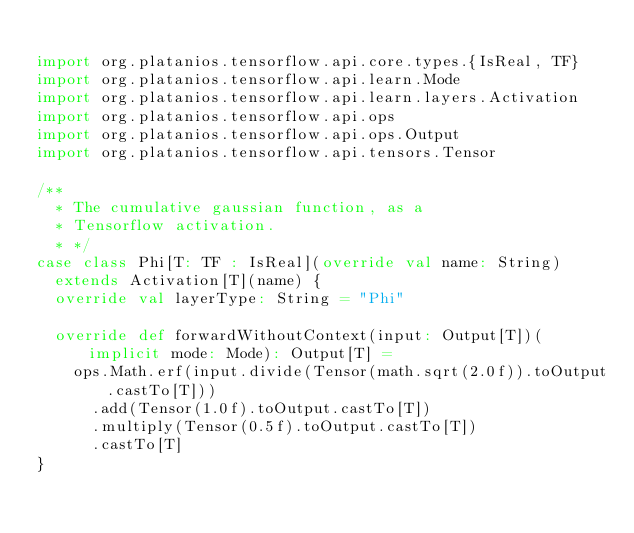<code> <loc_0><loc_0><loc_500><loc_500><_Scala_>
import org.platanios.tensorflow.api.core.types.{IsReal, TF}
import org.platanios.tensorflow.api.learn.Mode
import org.platanios.tensorflow.api.learn.layers.Activation
import org.platanios.tensorflow.api.ops
import org.platanios.tensorflow.api.ops.Output
import org.platanios.tensorflow.api.tensors.Tensor

/**
  * The cumulative gaussian function, as a
  * Tensorflow activation.
  * */
case class Phi[T: TF : IsReal](override val name: String)
  extends Activation[T](name) {
  override val layerType: String = "Phi"

  override def forwardWithoutContext(input: Output[T])(implicit mode: Mode): Output[T] =
    ops.Math.erf(input.divide(Tensor(math.sqrt(2.0f)).toOutput.castTo[T]))
      .add(Tensor(1.0f).toOutput.castTo[T])
      .multiply(Tensor(0.5f).toOutput.castTo[T])
      .castTo[T]
}</code> 